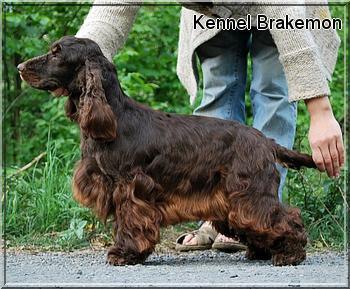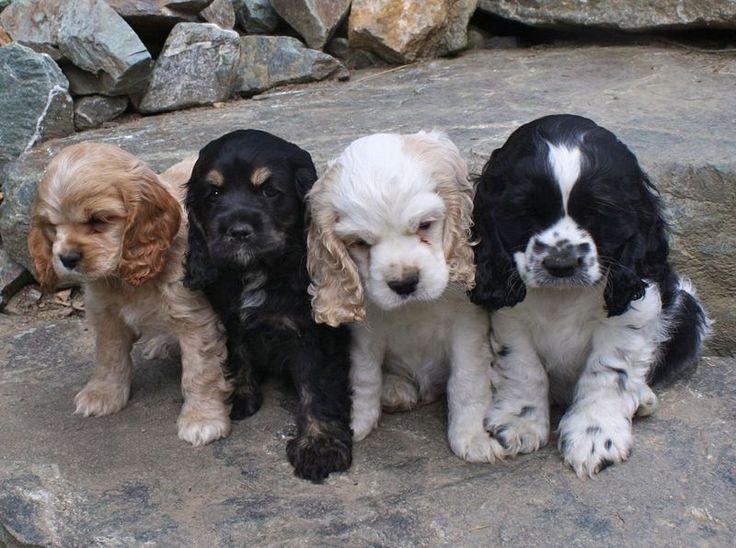The first image is the image on the left, the second image is the image on the right. Evaluate the accuracy of this statement regarding the images: "A black-and-tan dog sits upright on the left of a golden haired dog that also sits upright.". Is it true? Answer yes or no. No. The first image is the image on the left, the second image is the image on the right. Considering the images on both sides, is "The right image contains at least three dogs." valid? Answer yes or no. Yes. 